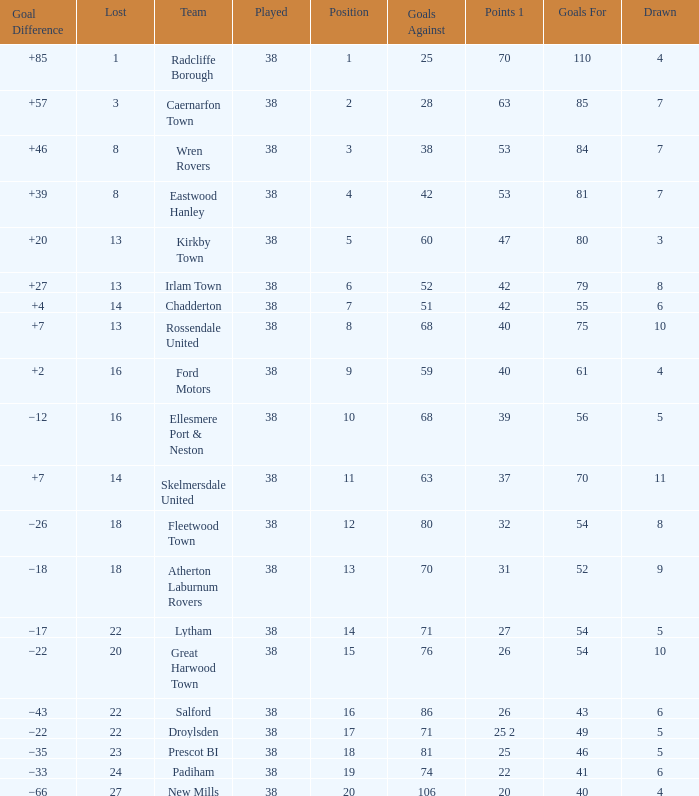Which Played has a Drawn of 4, and a Position of 9, and Goals Against larger than 59? None. 